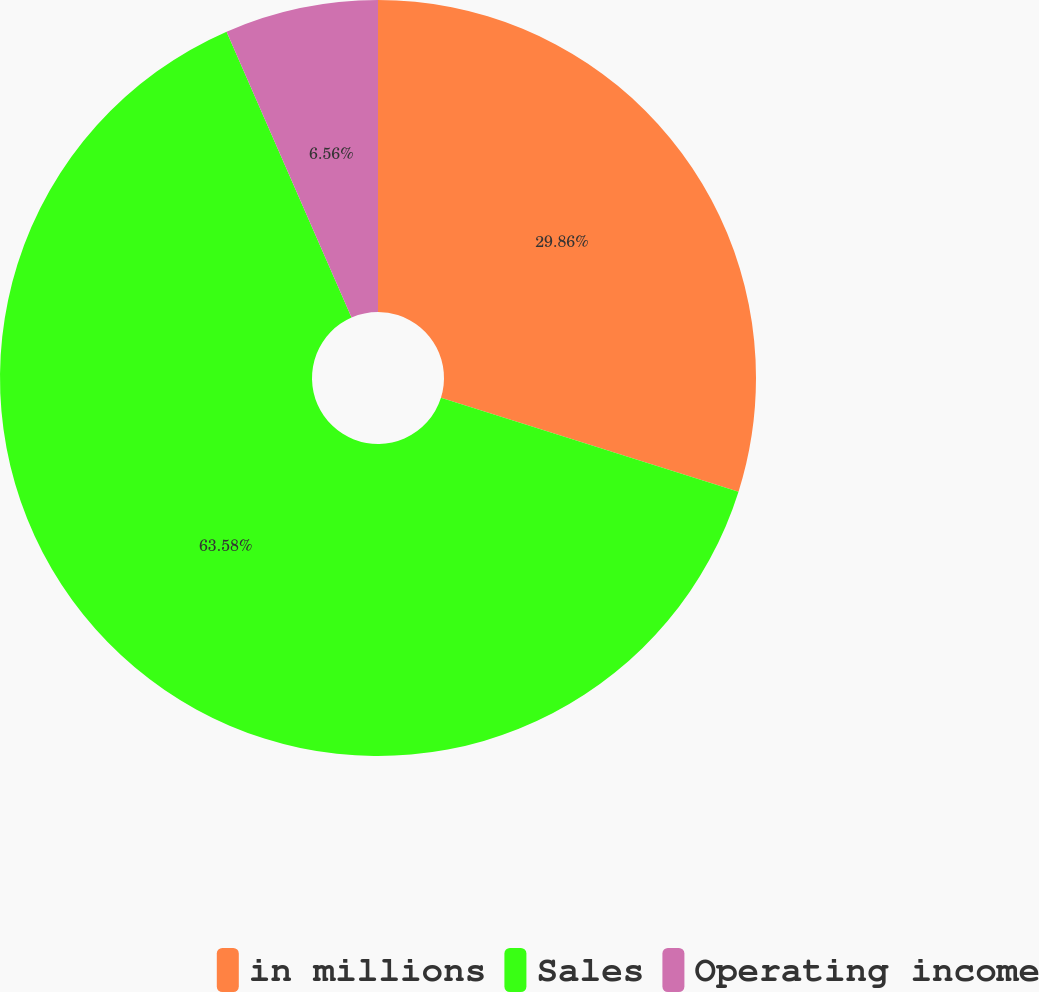Convert chart to OTSL. <chart><loc_0><loc_0><loc_500><loc_500><pie_chart><fcel>in millions<fcel>Sales<fcel>Operating income<nl><fcel>29.86%<fcel>63.58%<fcel>6.56%<nl></chart> 